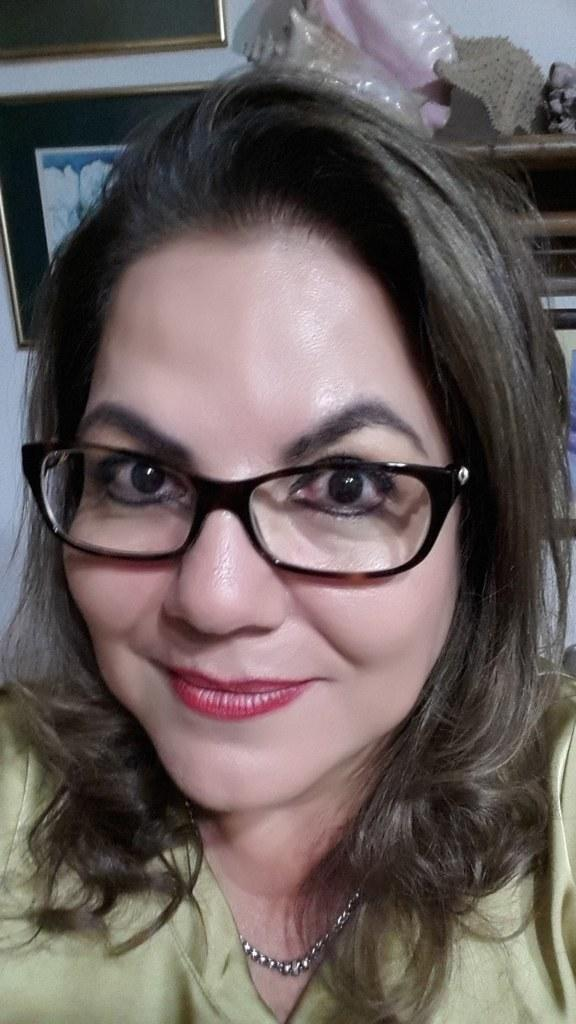Who is the main subject in the foreground of the image? There is a woman in the foreground of the image. What is the woman wearing in the image? The woman is wearing spectacles in the image. What can be seen in the background of the image? There are photo frames and other objects in the background of the image. What type of structure is visible in the background of the image? There is a wall in the background of the image. Can you tell me how many clovers are on the woman's face in the image? There are no clovers present on the woman's face in the image. Why is the woman crying in the image? There is no indication in the image that the woman is crying; she is simply wearing spectacles and standing in the foreground. 